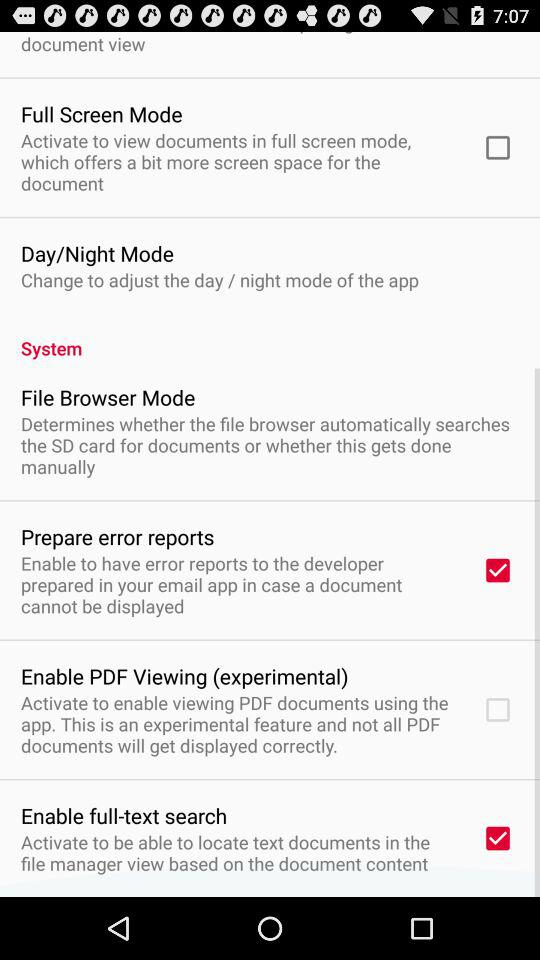How many of the items have a checkbox?
Answer the question using a single word or phrase. 4 